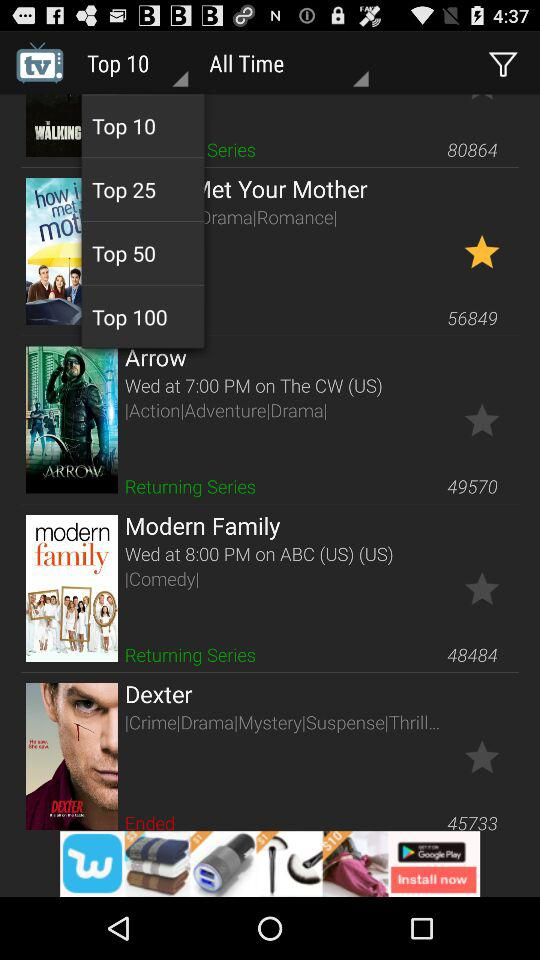How many people have rated "Arrow"? "Arrow" has been rated by 49,570 people. 